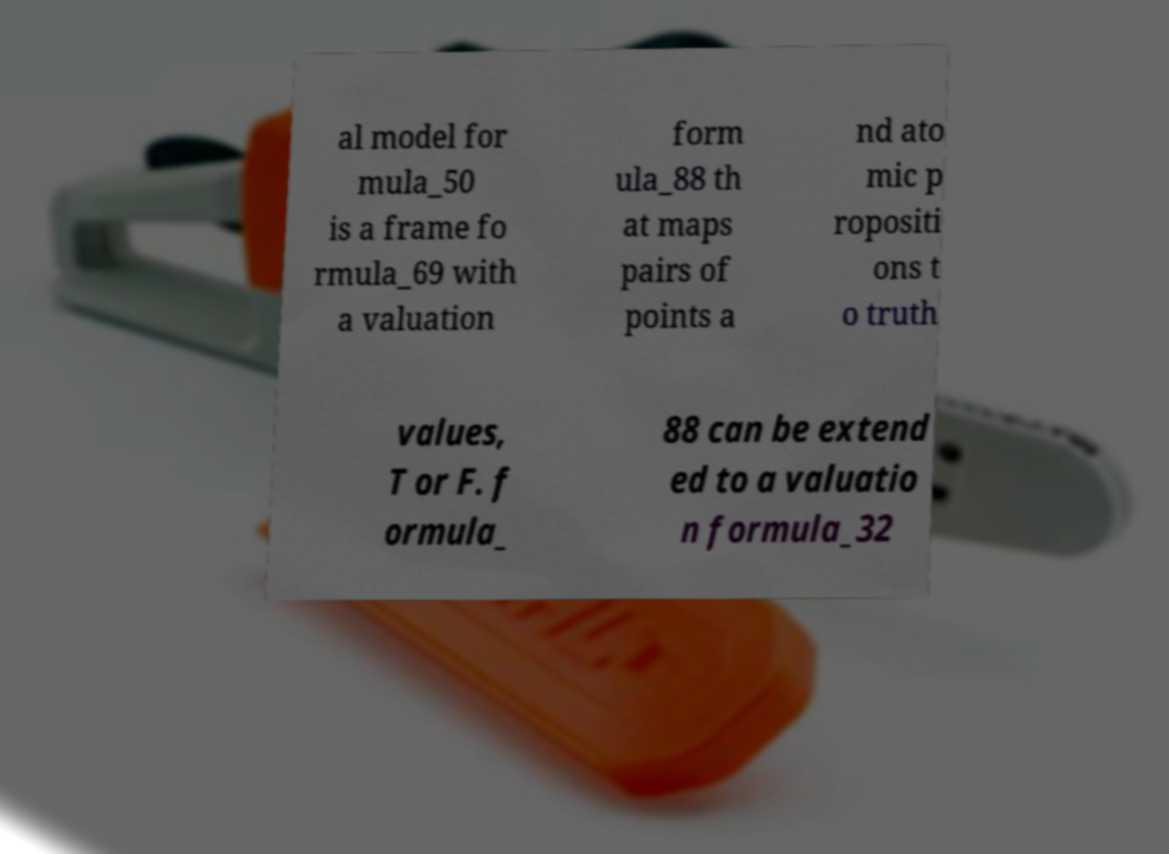Could you extract and type out the text from this image? al model for mula_50 is a frame fo rmula_69 with a valuation form ula_88 th at maps pairs of points a nd ato mic p ropositi ons t o truth values, T or F. f ormula_ 88 can be extend ed to a valuatio n formula_32 